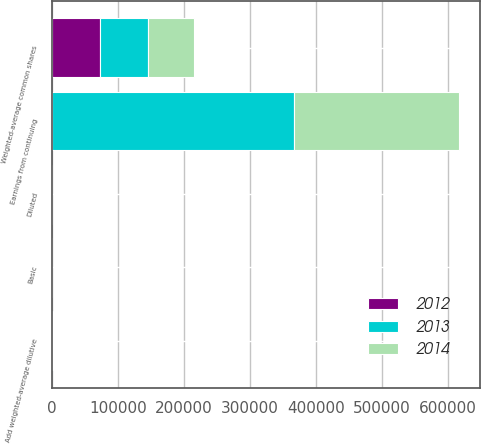<chart> <loc_0><loc_0><loc_500><loc_500><stacked_bar_chart><ecel><fcel>Earnings from continuing<fcel>Weighted-average common shares<fcel>Add weighted-average dilutive<fcel>Basic<fcel>Diluted<nl><fcel>2012<fcel>528<fcel>73363<fcel>526<fcel>7.3<fcel>7.25<nl><fcel>2013<fcel>366681<fcel>72301<fcel>528<fcel>5.11<fcel>5.07<nl><fcel>2014<fcel>250258<fcel>69306<fcel>318<fcel>3.63<fcel>3.61<nl></chart> 